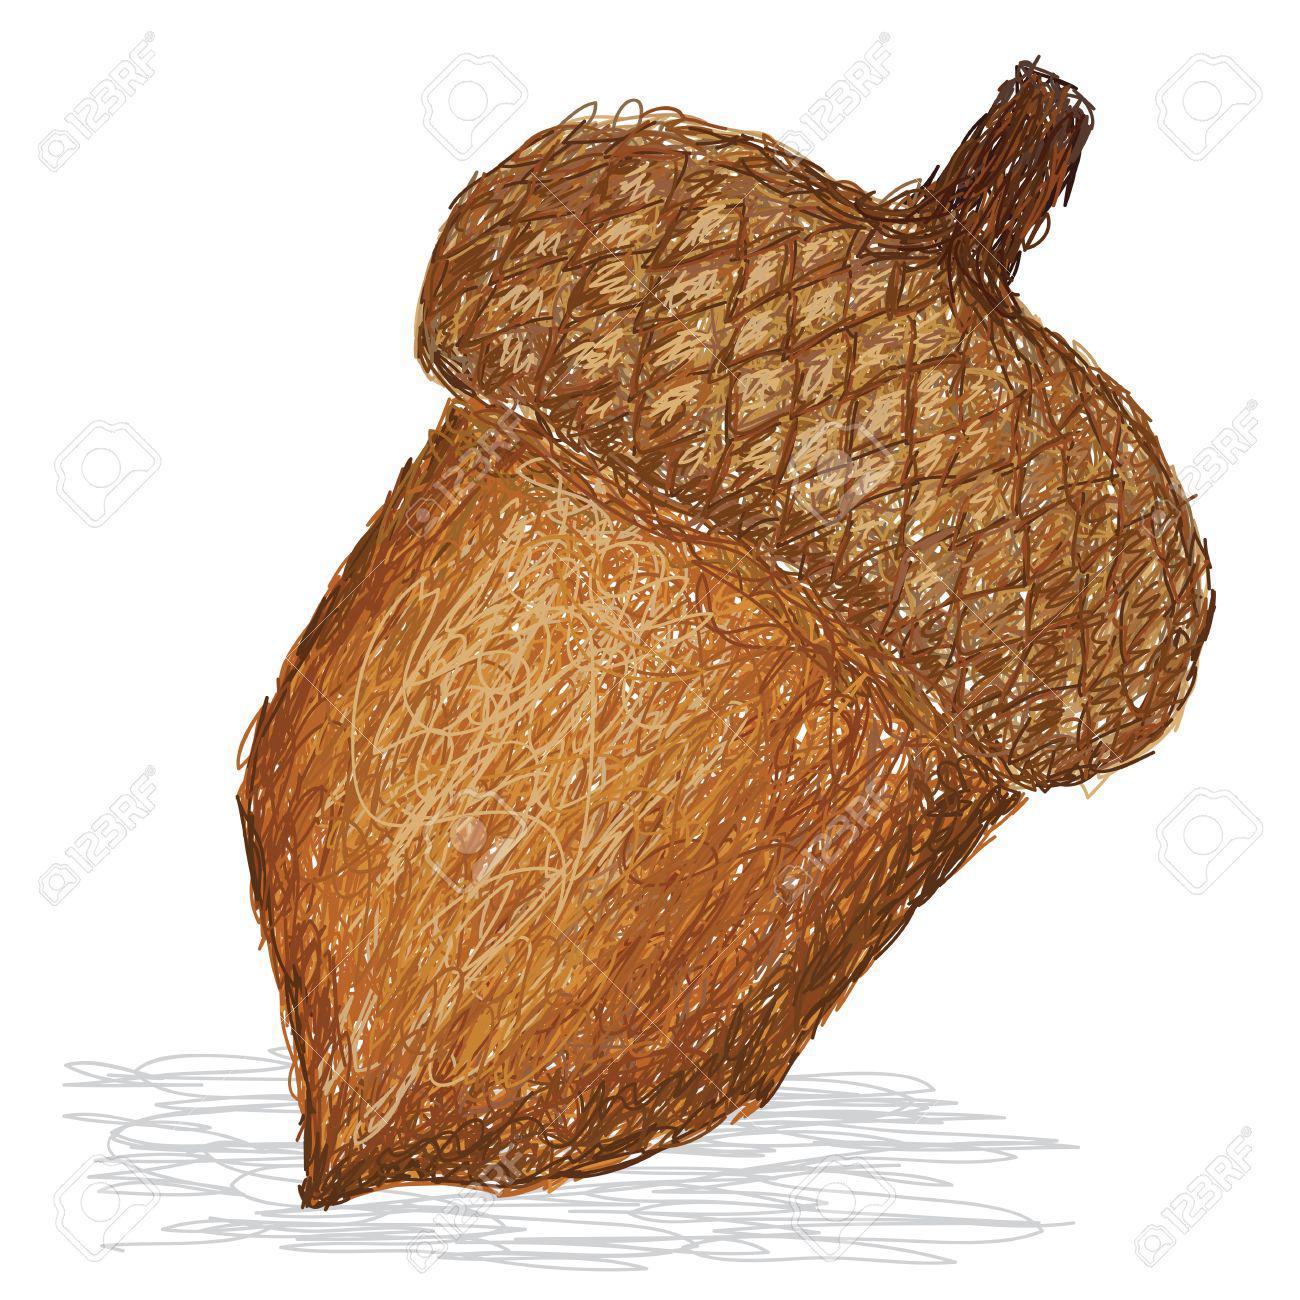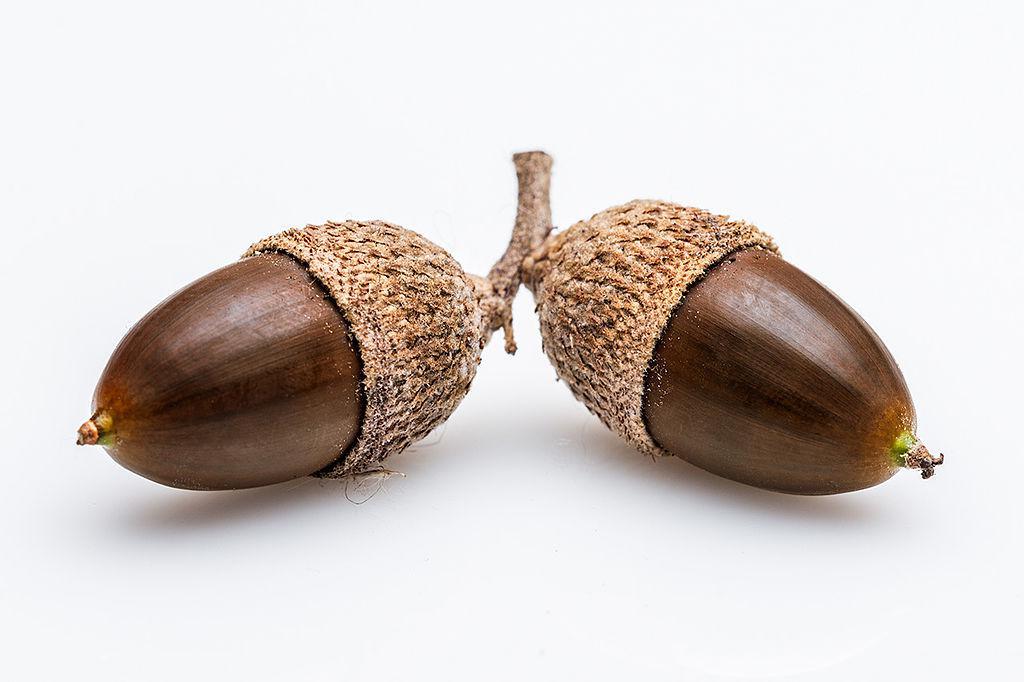The first image is the image on the left, the second image is the image on the right. Evaluate the accuracy of this statement regarding the images: "One picture shows at least three acorns next to each other.". Is it true? Answer yes or no. No. The first image is the image on the left, the second image is the image on the right. Examine the images to the left and right. Is the description "There are more items in the right image than in the left image." accurate? Answer yes or no. Yes. 